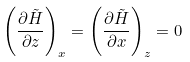Convert formula to latex. <formula><loc_0><loc_0><loc_500><loc_500>\left ( \frac { \partial \tilde { H } } { \partial z } \right ) _ { x } = \left ( \frac { \partial \tilde { H } } { \partial x } \right ) _ { z } = 0</formula> 